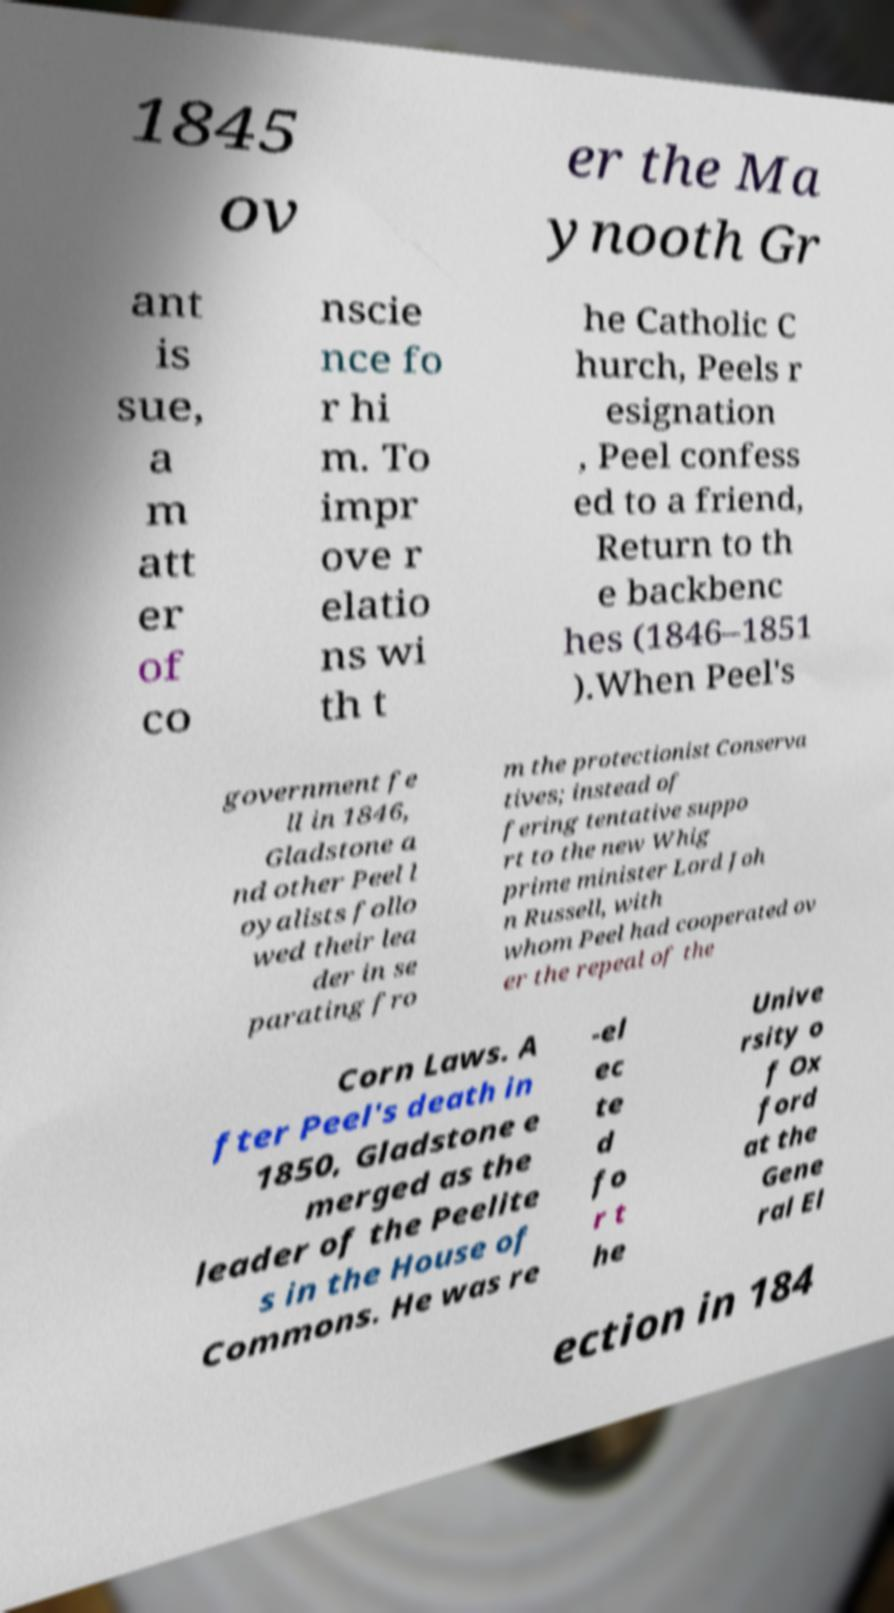Please identify and transcribe the text found in this image. 1845 ov er the Ma ynooth Gr ant is sue, a m att er of co nscie nce fo r hi m. To impr ove r elatio ns wi th t he Catholic C hurch, Peels r esignation , Peel confess ed to a friend, Return to th e backbenc hes (1846–1851 ).When Peel's government fe ll in 1846, Gladstone a nd other Peel l oyalists follo wed their lea der in se parating fro m the protectionist Conserva tives; instead of fering tentative suppo rt to the new Whig prime minister Lord Joh n Russell, with whom Peel had cooperated ov er the repeal of the Corn Laws. A fter Peel's death in 1850, Gladstone e merged as the leader of the Peelite s in the House of Commons. He was re -el ec te d fo r t he Unive rsity o f Ox ford at the Gene ral El ection in 184 